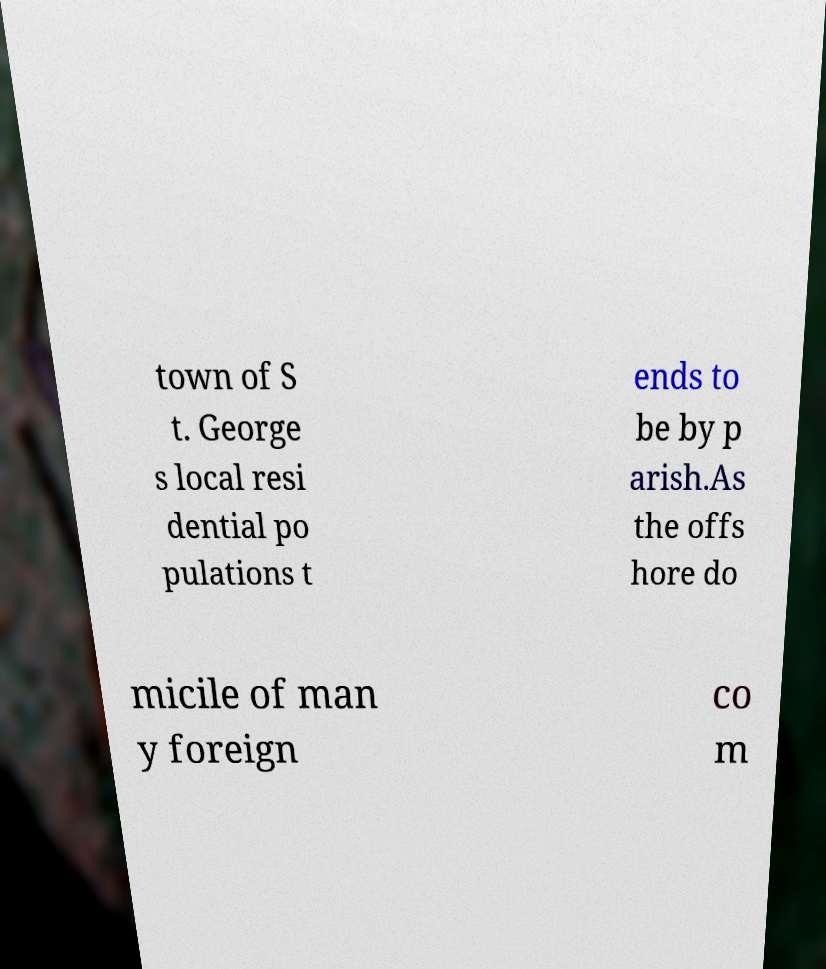Could you assist in decoding the text presented in this image and type it out clearly? town of S t. George s local resi dential po pulations t ends to be by p arish.As the offs hore do micile of man y foreign co m 